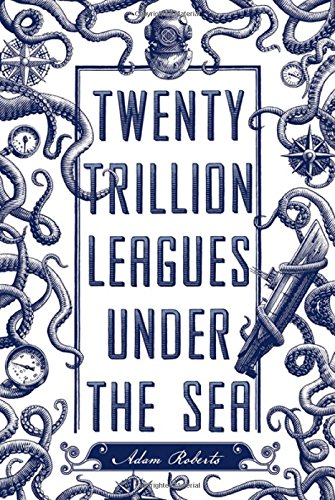Is this a journey related book? Indeed, this book is related to a journey, specifically an underwater voyage that hints at adventure and discovery, in the spirit of Jules Verne's original oceanic expedition. 